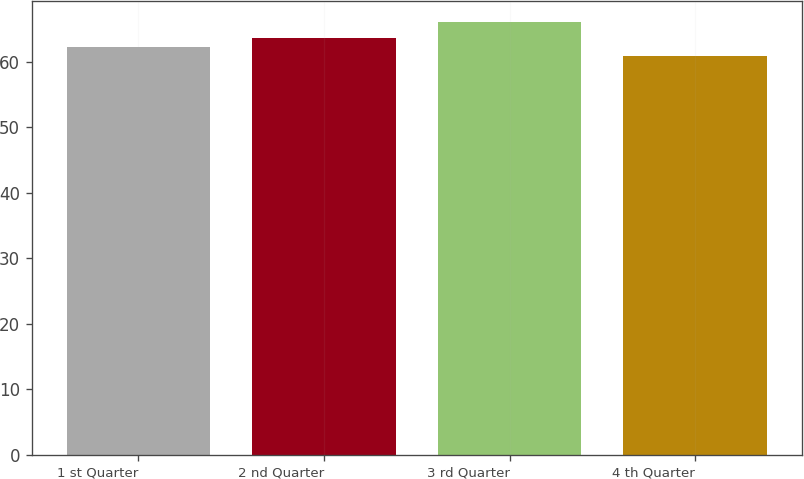Convert chart. <chart><loc_0><loc_0><loc_500><loc_500><bar_chart><fcel>1 st Quarter<fcel>2 nd Quarter<fcel>3 rd Quarter<fcel>4 th Quarter<nl><fcel>62.26<fcel>63.64<fcel>65.98<fcel>60.83<nl></chart> 